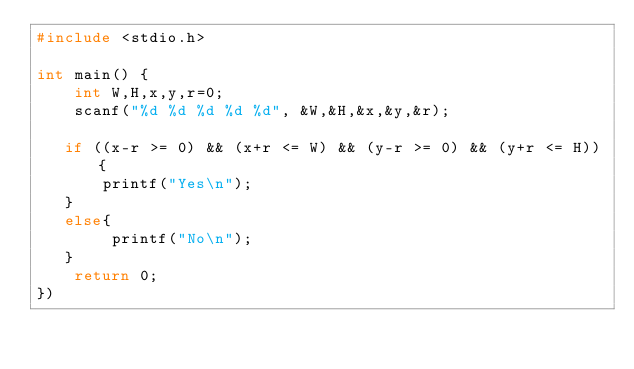Convert code to text. <code><loc_0><loc_0><loc_500><loc_500><_C_>#include <stdio.h>

int main() {
    int W,H,x,y,r=0;
    scanf("%d %d %d %d %d", &W,&H,&x,&y,&r);
    
   if ((x-r >= 0) && (x+r <= W) && (y-r >= 0) && (y+r <= H)){
       printf("Yes\n");
   }
   else{
        printf("No\n");
   }
    return 0;    
})
</code> 